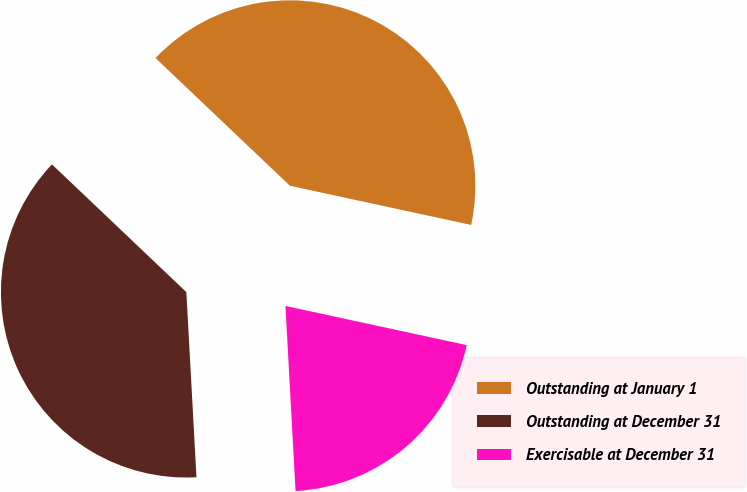Convert chart to OTSL. <chart><loc_0><loc_0><loc_500><loc_500><pie_chart><fcel>Outstanding at January 1<fcel>Outstanding at December 31<fcel>Exercisable at December 31<nl><fcel>41.29%<fcel>37.96%<fcel>20.74%<nl></chart> 